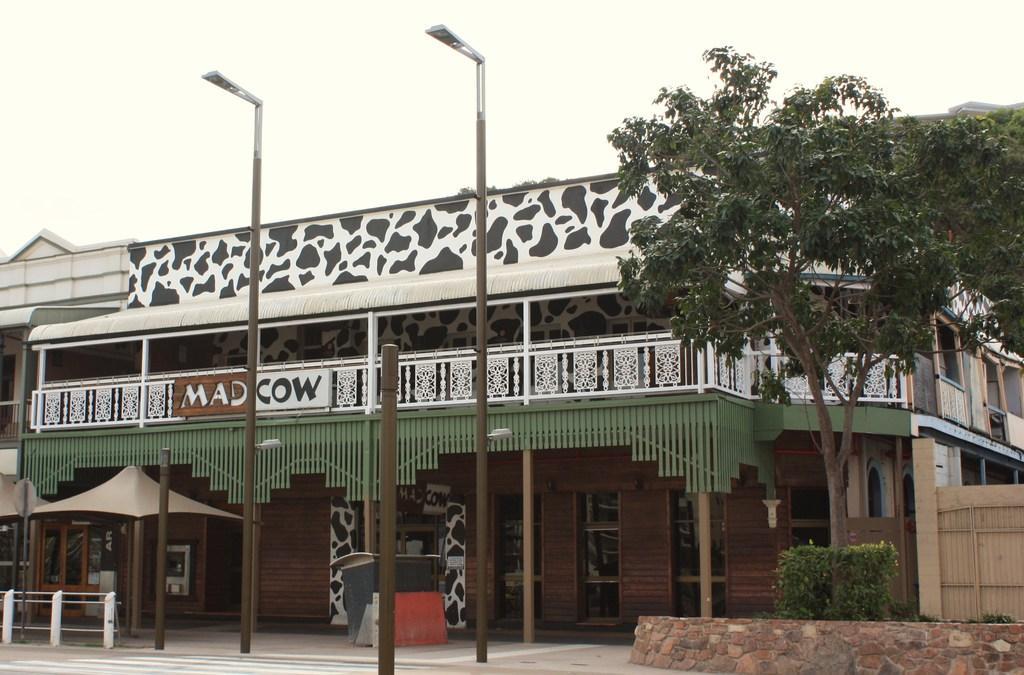Can you describe this image briefly? In this picture I can observe a building. There are some poles in the middle of the picture. On the right side there are trees and plants on the ground. In the background there is a sky. 